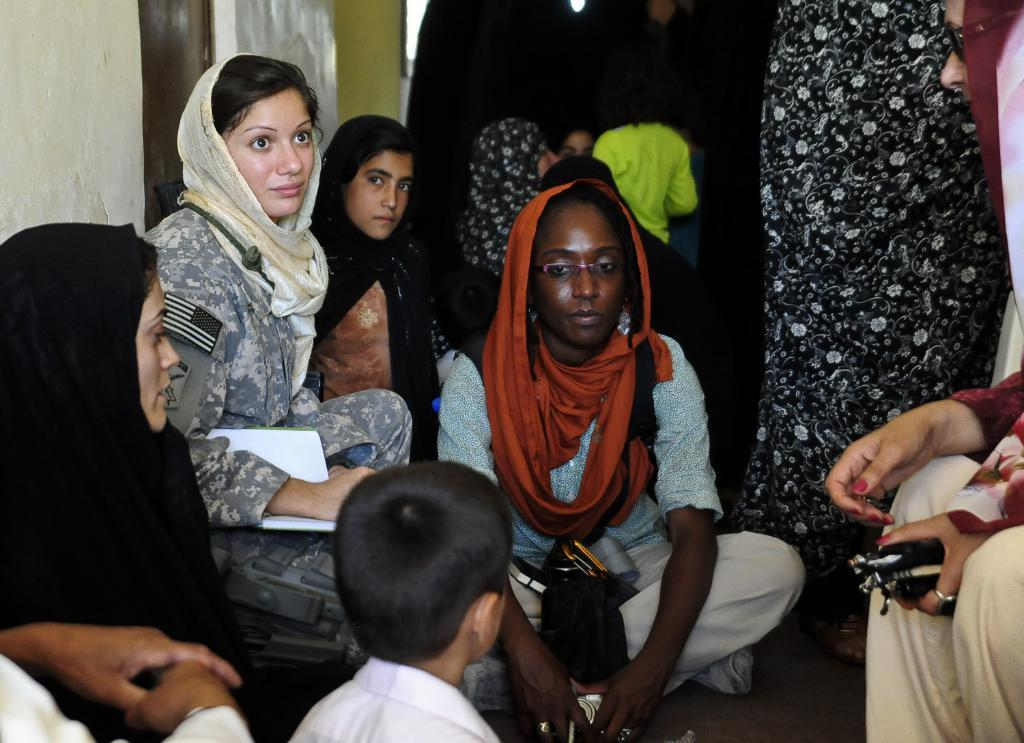What can be seen in the image involving multiple individuals? There is a group of people in the image. Can you describe the woman in the image? There is a woman in the image, and she is smiling. What else is present in the image besides the people? There are objects in the image. What can be seen in the background of the image? There is a wall in the background of the image. What type of cake is being used for the magic trick in the image? There is no cake or magic trick present in the image. What kind of beast is lurking in the background of the image? There is no beast present in the image; only a wall can be seen in the background. 